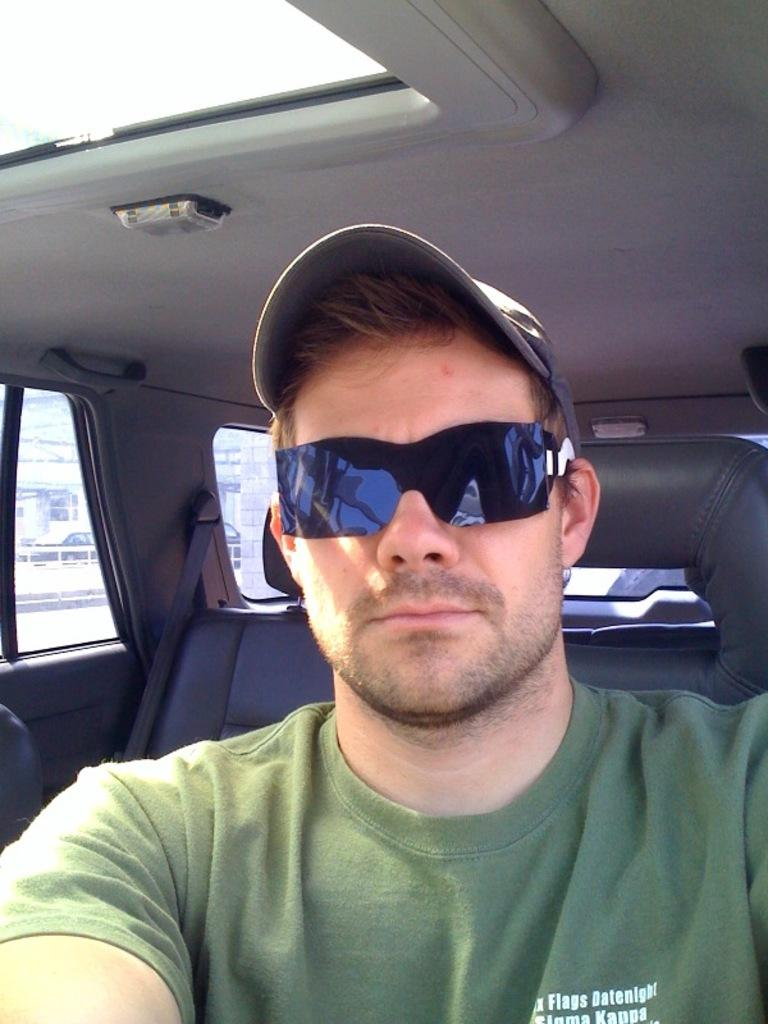Who is present in the image? There is a man in the image. What is the man wearing on his face? The man is wearing spectacles. What is the man wearing on his head? The man is wearing a cap. Where is the man located in the image? The man is seated in a car. How does the car respond to the earthquake in the image? There is no earthquake present in the image, so the car's response cannot be determined. 